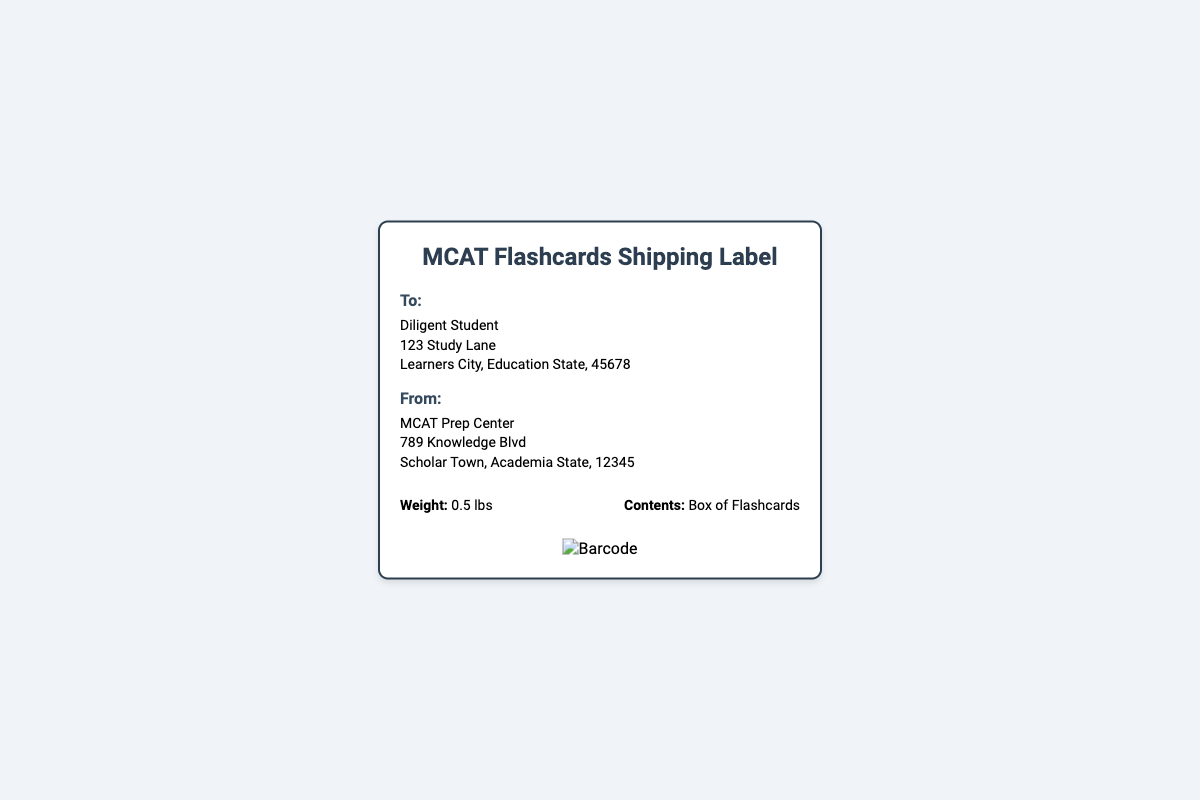What is the weight of the package? The weight of the package is explicitly stated in the details section of the document.
Answer: 0.5 lbs Who is the recipient of the flashcards? The recipient's name is noted in the "To" section at the top of the address part of the document.
Answer: Diligent Student What is the sender's address? The sender's address is provided in the "From" section, detailing the location from which the item is shipped.
Answer: MCAT Prep Center, 789 Knowledge Blvd, Scholar Town, Academia State, 12345 What type of contents are inside the package? The contents of the package are mentioned in the details section, indicating what is being shipped.
Answer: Box of Flashcards What is the city of the recipient? The city of the recipient is included in the address section of the document.
Answer: Learners City How many total addresses are listed on the shipping label? The document contains separate "To" and "From" sections, which both include addresses.
Answer: 2 What is the main purpose of this document? The purpose of this document is to indicate information about the shipping of the flashcards.
Answer: Shipping label Is there a barcode included in the document? The document features a visual section at the bottom dedicated to a barcode image.
Answer: Yes 